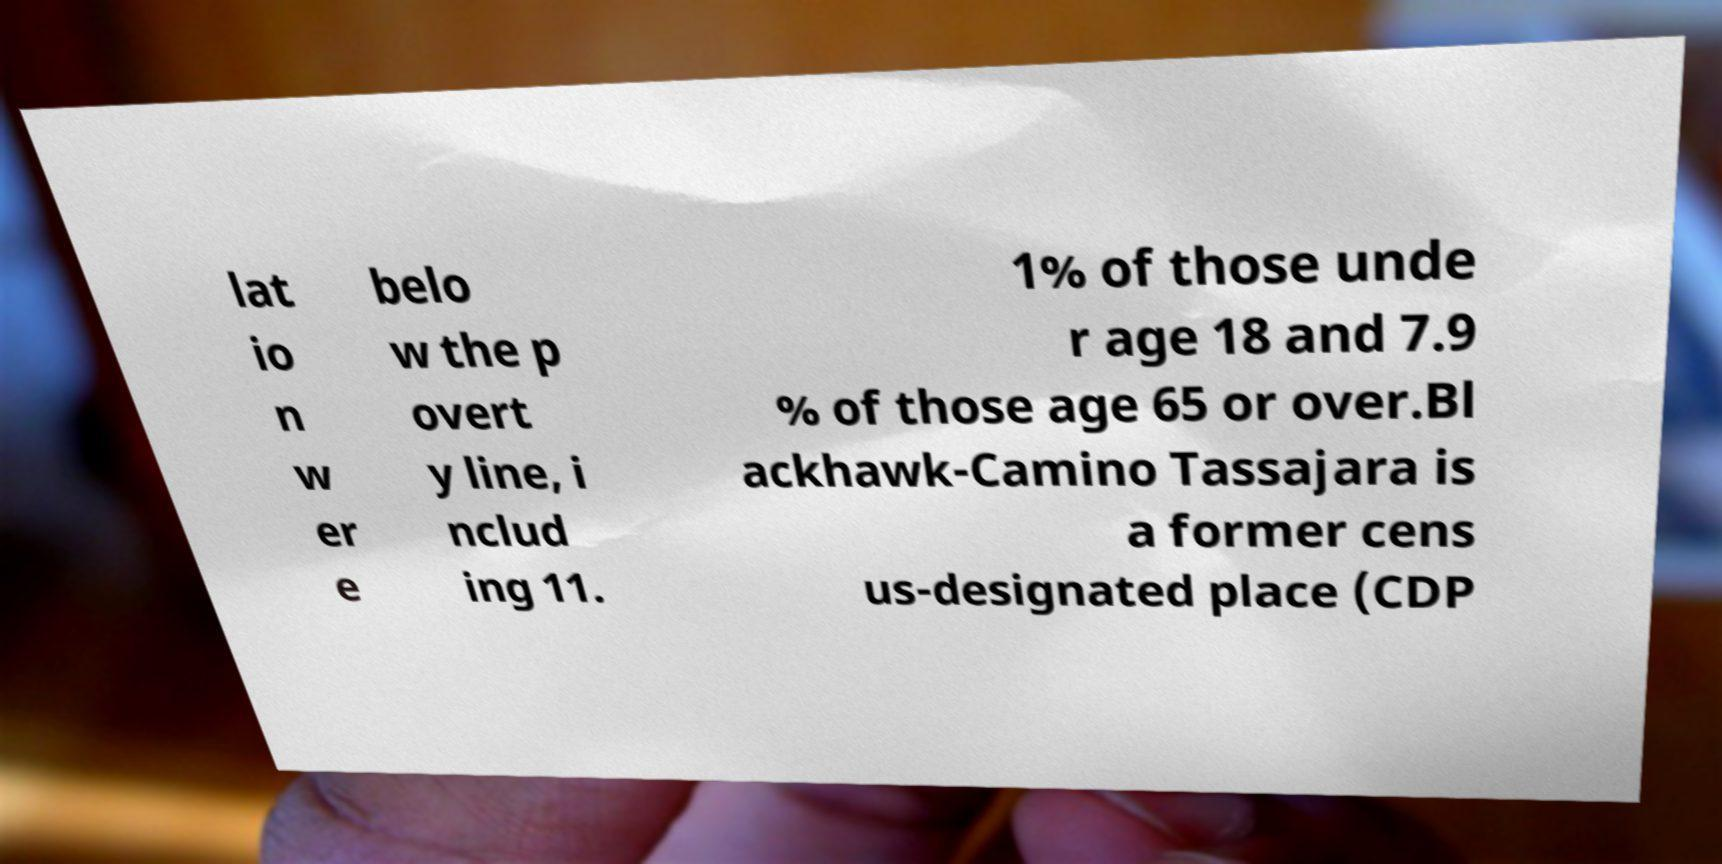Could you extract and type out the text from this image? lat io n w er e belo w the p overt y line, i nclud ing 11. 1% of those unde r age 18 and 7.9 % of those age 65 or over.Bl ackhawk-Camino Tassajara is a former cens us-designated place (CDP 